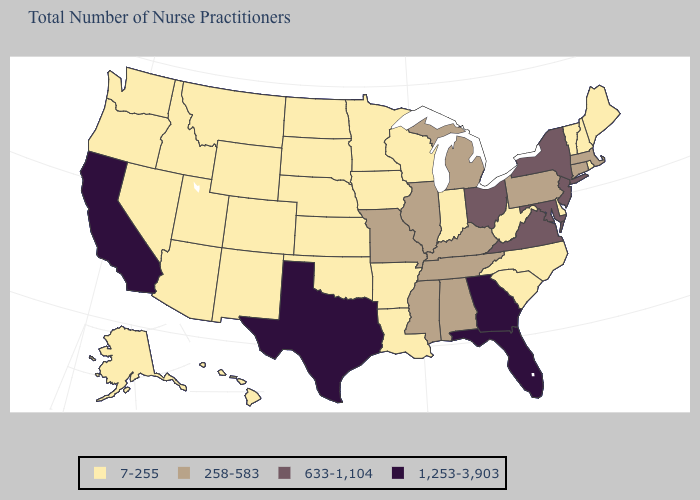Does Virginia have a lower value than New Jersey?
Write a very short answer. No. What is the value of Pennsylvania?
Be succinct. 258-583. Does the first symbol in the legend represent the smallest category?
Concise answer only. Yes. Does Hawaii have the highest value in the West?
Be succinct. No. Name the states that have a value in the range 633-1,104?
Concise answer only. Maryland, New Jersey, New York, Ohio, Virginia. What is the value of Nebraska?
Concise answer only. 7-255. Does the map have missing data?
Give a very brief answer. No. Among the states that border Oregon , does Washington have the lowest value?
Short answer required. Yes. Does Alabama have the same value as North Dakota?
Quick response, please. No. Which states have the lowest value in the USA?
Answer briefly. Alaska, Arizona, Arkansas, Colorado, Delaware, Hawaii, Idaho, Indiana, Iowa, Kansas, Louisiana, Maine, Minnesota, Montana, Nebraska, Nevada, New Hampshire, New Mexico, North Carolina, North Dakota, Oklahoma, Oregon, Rhode Island, South Carolina, South Dakota, Utah, Vermont, Washington, West Virginia, Wisconsin, Wyoming. Name the states that have a value in the range 1,253-3,903?
Quick response, please. California, Florida, Georgia, Texas. Among the states that border Illinois , which have the lowest value?
Write a very short answer. Indiana, Iowa, Wisconsin. What is the highest value in the Northeast ?
Give a very brief answer. 633-1,104. Name the states that have a value in the range 7-255?
Short answer required. Alaska, Arizona, Arkansas, Colorado, Delaware, Hawaii, Idaho, Indiana, Iowa, Kansas, Louisiana, Maine, Minnesota, Montana, Nebraska, Nevada, New Hampshire, New Mexico, North Carolina, North Dakota, Oklahoma, Oregon, Rhode Island, South Carolina, South Dakota, Utah, Vermont, Washington, West Virginia, Wisconsin, Wyoming. Does South Carolina have the highest value in the USA?
Quick response, please. No. 